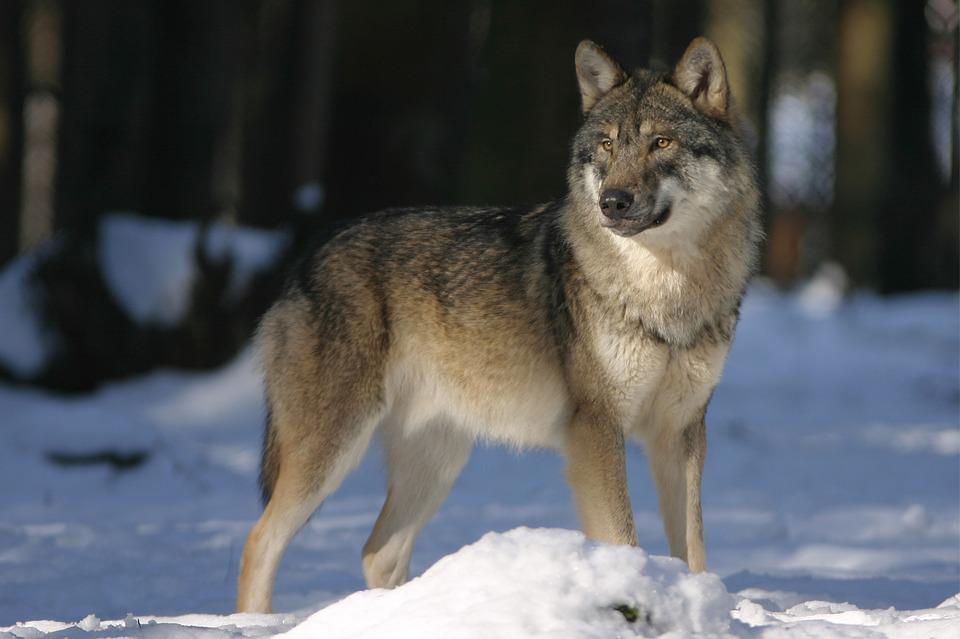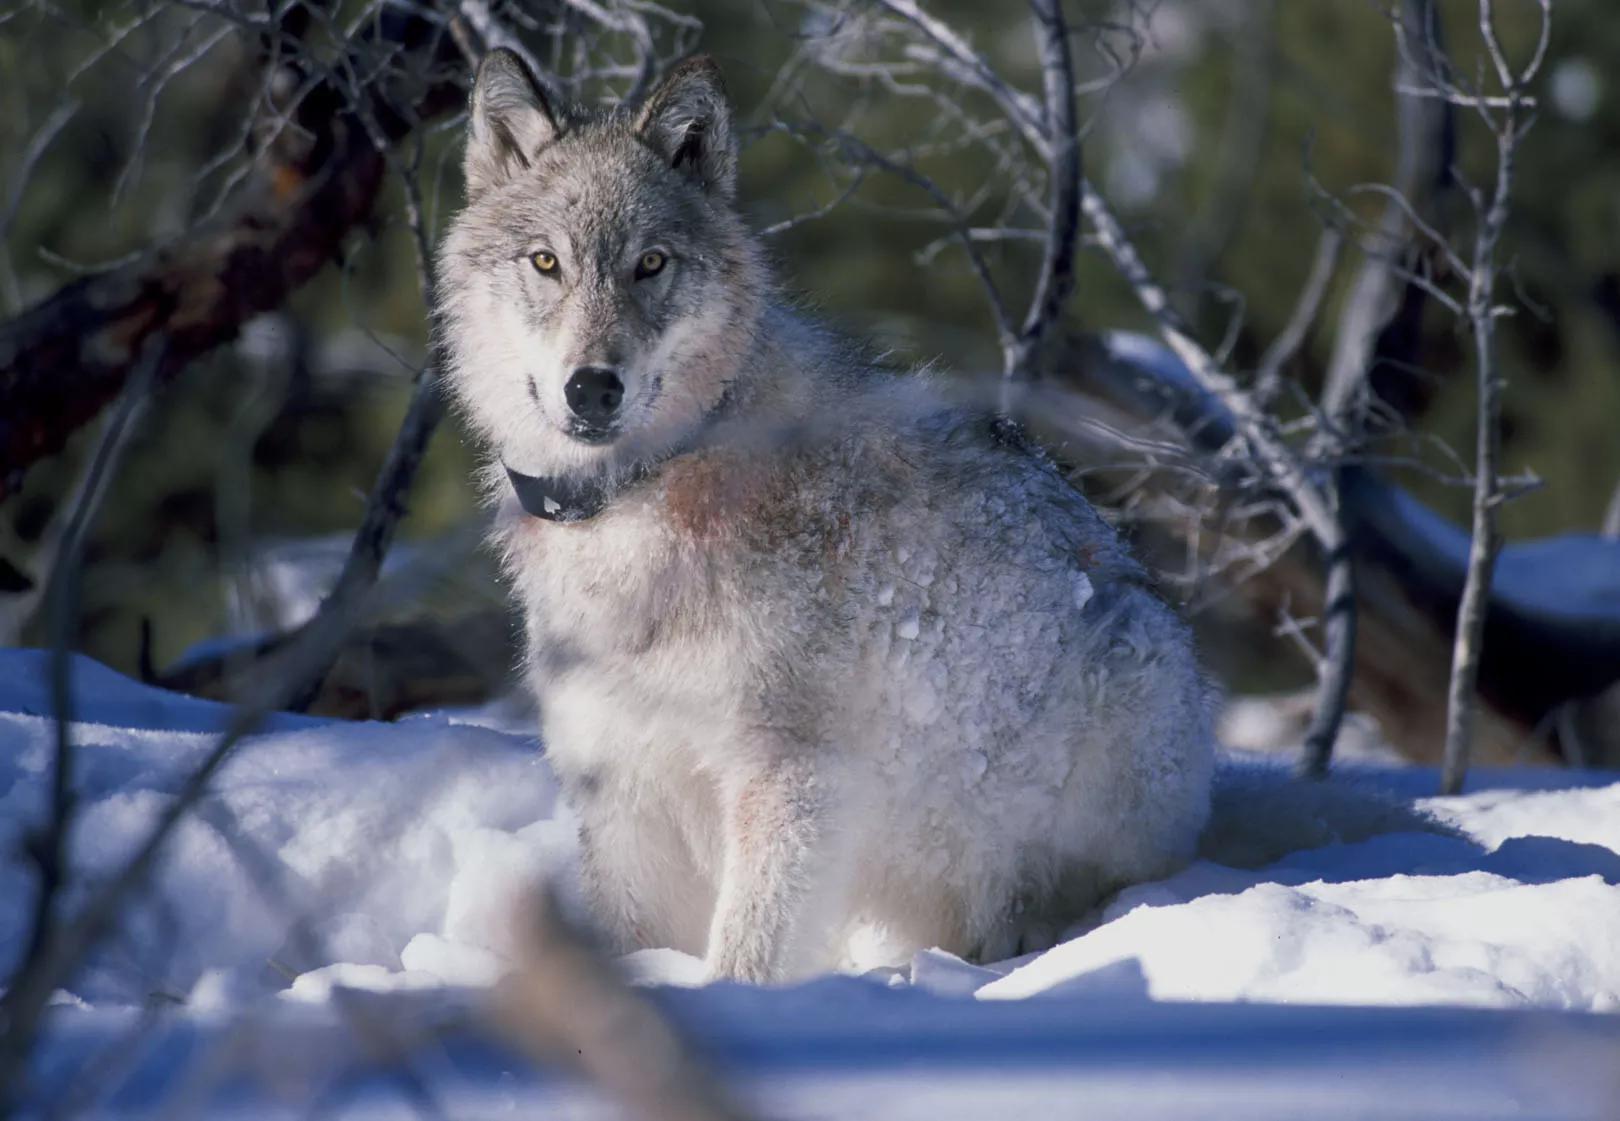The first image is the image on the left, the second image is the image on the right. Considering the images on both sides, is "There is a wolf sitting in the snow" valid? Answer yes or no. Yes. 